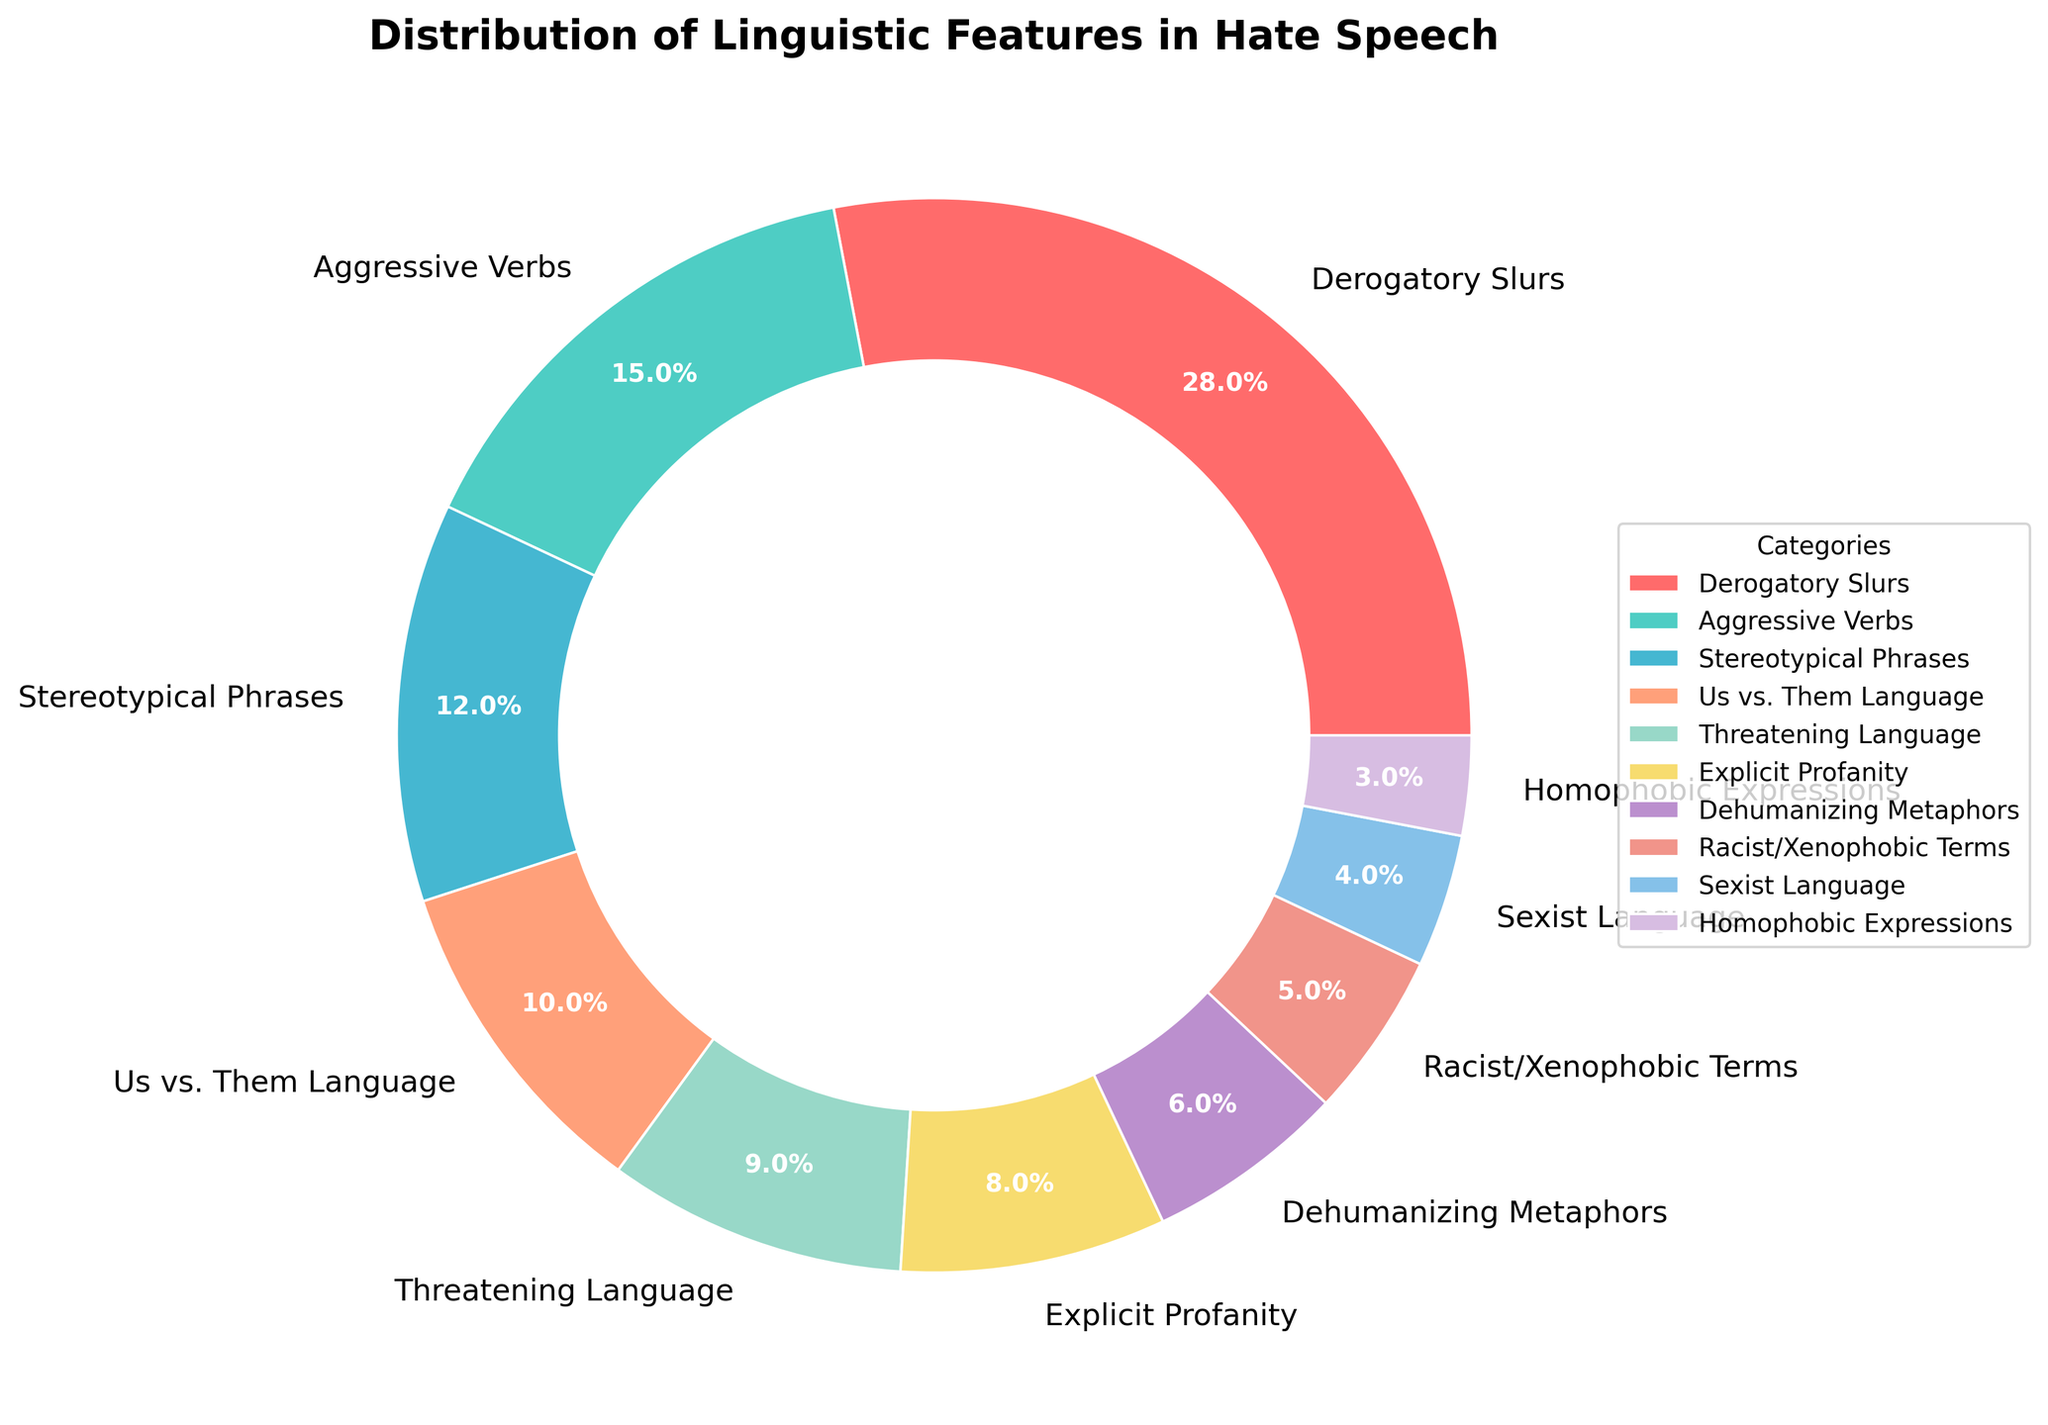What is the largest category in the pie chart? The largest category is determined by the highest percentage in the pie chart. From the data, the category "Derogatory Slurs" has 28%, which is the highest.
Answer: Derogatory Slurs Which category has the lowest percentage? The lowest percentage can be found by identifying the smallest value in the pie chart. "Homophobic Expressions" has the smallest percentage at 3%.
Answer: Homophobic Expressions What is the combined percentage of "Aggressive Verbs" and "Threatening Language"? To find the combined percentage, add the percentages of "Aggressive Verbs" (15%) and "Threatening Language" (9%). 15% + 9% = 24%.
Answer: 24% Is the percentage of "Explicit Profanity" greater than "Dehumanizing Metaphors"? Compare the percentages: "Explicit Profanity" is 8% and "Dehumanizing Metaphors" is 6%. Since 8% is greater than 6%, yes, it is greater.
Answer: Yes What is the difference in percentage between "Stereotypical Phrases" and "Racist/Xenophobic Terms"? Subtract the percentage of "Racist/Xenophobic Terms" (5%) from "Stereotypical Phrases" (12%). 12% - 5% = 7%.
Answer: 7% How many categories have a percentage higher than 10%? Count the categories with percentages higher than 10%. "Derogatory Slurs" (28%), "Aggressive Verbs" (15%), and "Stereotypical Phrases" (12%) are the ones above 10%. Therefore, there are 3 categories.
Answer: 3 What is the average percentage of "Us vs. Them Language", "Racist/Xenophobic Terms", and "Sexist Language"? Sum the percentages: 10% (Us vs. Them Language) + 5% (Racist/Xenophobic Terms) + 4% (Sexist Language) = 19%. Then, divide by the number of categories: 19% / 3 = 6.33%.
Answer: 6.33% Which categories are represented by the colors blue and orange? Look at the colors used in the pie chart and identify the corresponding labels. Blue corresponds to "Aggressive Verbs" and orange corresponds to "Us vs. Them Language".
Answer: Aggressive Verbs and Us vs. Them Language What is the total percentage of categories related to discriminatory language (Derogatory Slurs, Racist/Xenophobic Terms, Homophobic Expressions, Sexist Language)? Sum the percentages of the discriminatory categories: 28% (Derogatory Slurs) + 5% (Racist/Xenophobic Terms) + 3% (Homophobic Expressions) + 4% (Sexist Language). The total is 40%.
Answer: 40% Is "Stereotypical Phrases" more prevalent than "Explicit Profanity" and "Dehumanizing Metaphors" combined? Sum the percentages of "Explicit Profanity" (8%) and "Dehumanizing Metaphors" (6%). The combined percentage is 14%. Since "Stereotypical Phrases" is 12%, it is not more prevalent.
Answer: No 